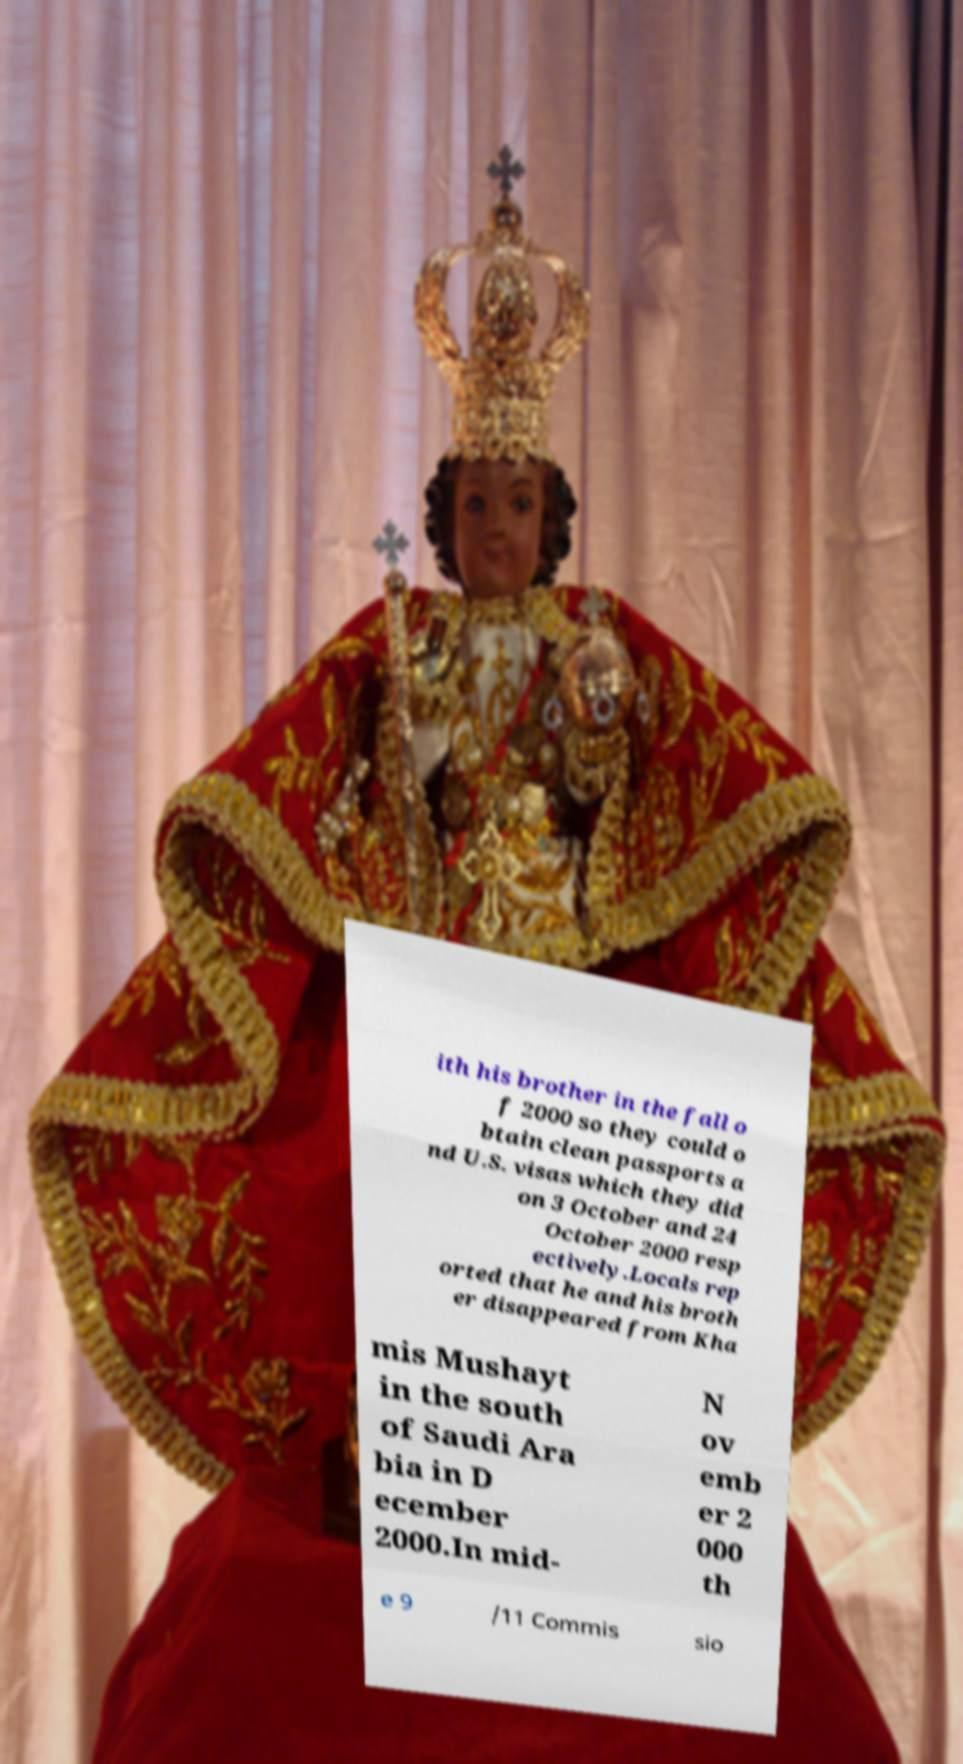For documentation purposes, I need the text within this image transcribed. Could you provide that? ith his brother in the fall o f 2000 so they could o btain clean passports a nd U.S. visas which they did on 3 October and 24 October 2000 resp ectively.Locals rep orted that he and his broth er disappeared from Kha mis Mushayt in the south of Saudi Ara bia in D ecember 2000.In mid- N ov emb er 2 000 th e 9 /11 Commis sio 